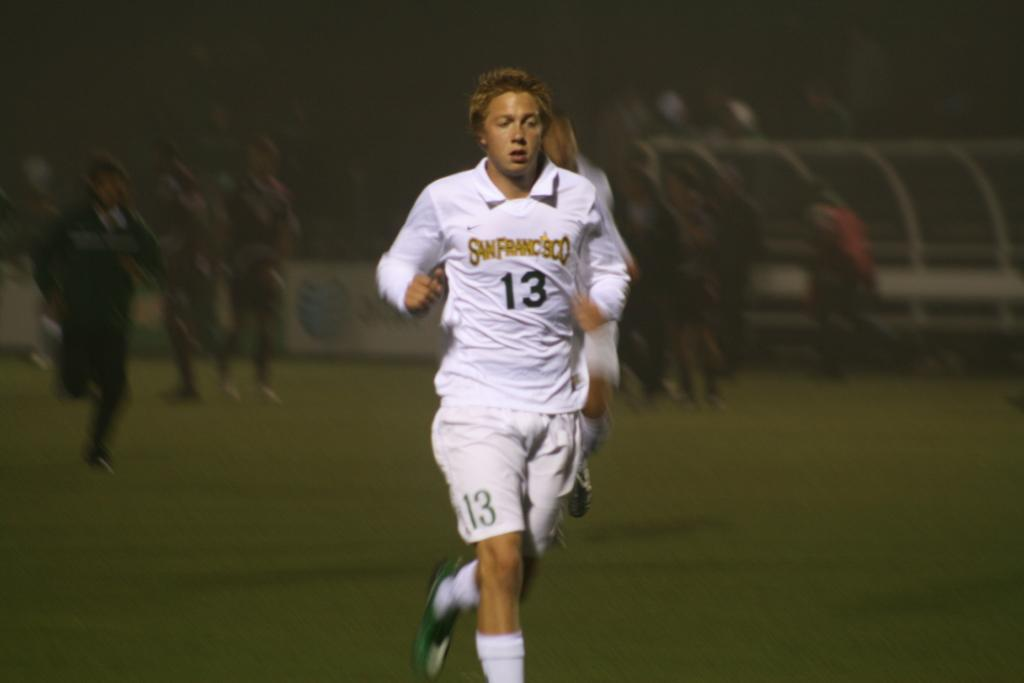<image>
Summarize the visual content of the image. Player #13 for San Francisco jogs down the field. 